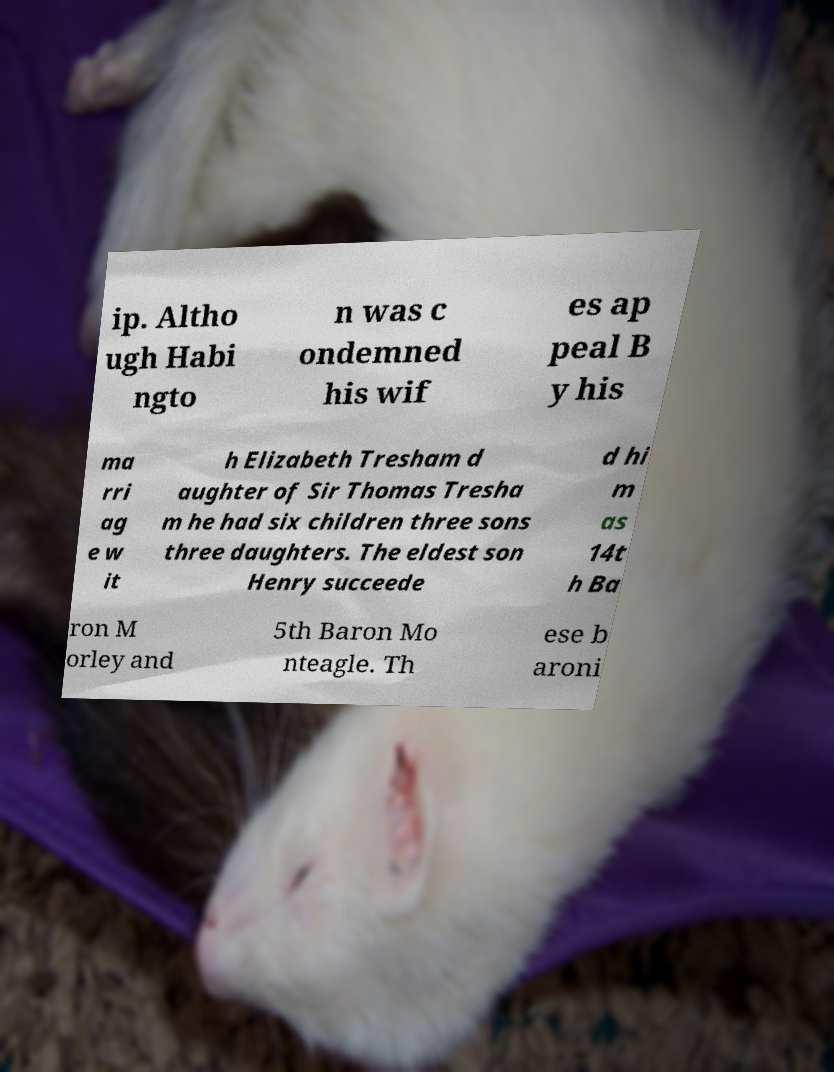For documentation purposes, I need the text within this image transcribed. Could you provide that? ip. Altho ugh Habi ngto n was c ondemned his wif es ap peal B y his ma rri ag e w it h Elizabeth Tresham d aughter of Sir Thomas Tresha m he had six children three sons three daughters. The eldest son Henry succeede d hi m as 14t h Ba ron M orley and 5th Baron Mo nteagle. Th ese b aroni 